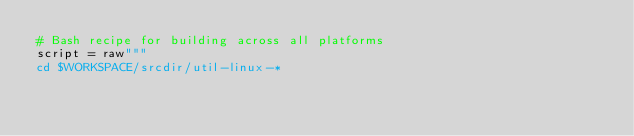Convert code to text. <code><loc_0><loc_0><loc_500><loc_500><_Julia_># Bash recipe for building across all platforms
script = raw"""
cd $WORKSPACE/srcdir/util-linux-*</code> 